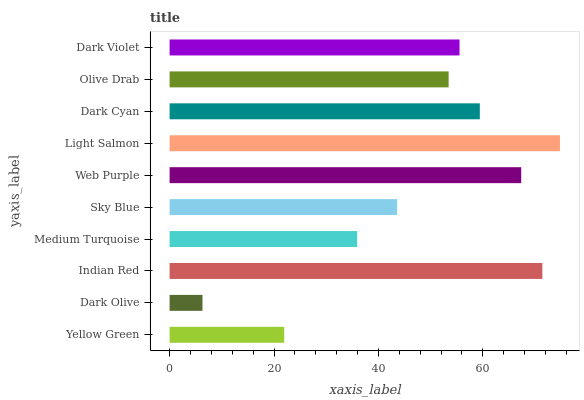Is Dark Olive the minimum?
Answer yes or no. Yes. Is Light Salmon the maximum?
Answer yes or no. Yes. Is Indian Red the minimum?
Answer yes or no. No. Is Indian Red the maximum?
Answer yes or no. No. Is Indian Red greater than Dark Olive?
Answer yes or no. Yes. Is Dark Olive less than Indian Red?
Answer yes or no. Yes. Is Dark Olive greater than Indian Red?
Answer yes or no. No. Is Indian Red less than Dark Olive?
Answer yes or no. No. Is Dark Violet the high median?
Answer yes or no. Yes. Is Olive Drab the low median?
Answer yes or no. Yes. Is Web Purple the high median?
Answer yes or no. No. Is Sky Blue the low median?
Answer yes or no. No. 